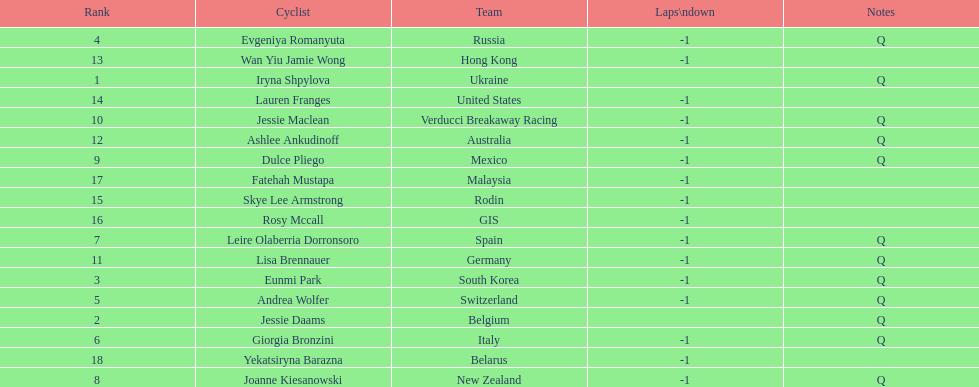How many cyclist do not have -1 laps down? 2. 